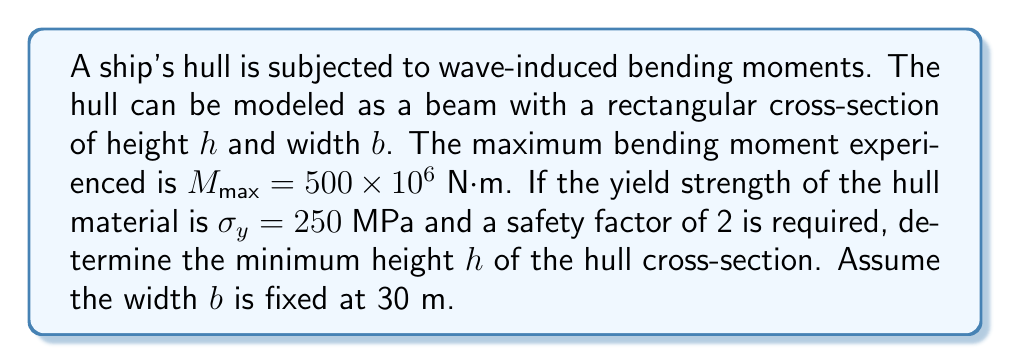Give your solution to this math problem. 1) The maximum stress in a beam due to bending is given by:

   $$\sigma_{max} = \frac{My}{I}$$

   where $M$ is the bending moment, $y$ is the distance from the neutral axis to the outermost fiber, and $I$ is the moment of inertia of the cross-section.

2) For a rectangular cross-section, $y = h/2$ and $I = bh^3/12$. Substituting these:

   $$\sigma_{max} = \frac{M(h/2)}{bh^3/12} = \frac{6M}{bh^2}$$

3) The maximum allowable stress is the yield strength divided by the safety factor:

   $$\sigma_{allowable} = \frac{\sigma_y}{SF} = \frac{250 \times 10^6}{2} = 125 \times 10^6 \text{ Pa}$$

4) Setting $\sigma_{max} = \sigma_{allowable}$:

   $$125 \times 10^6 = \frac{6(500 \times 10^6)}{30h^2}$$

5) Solving for $h$:

   $$h^2 = \frac{6(500 \times 10^6)}{30(125 \times 10^6)} = 0.8$$
   
   $$h = \sqrt{0.8} = 0.894 \text{ m}$$

6) Rounding up for safety, the minimum height should be 0.9 m.
Answer: 0.9 m 